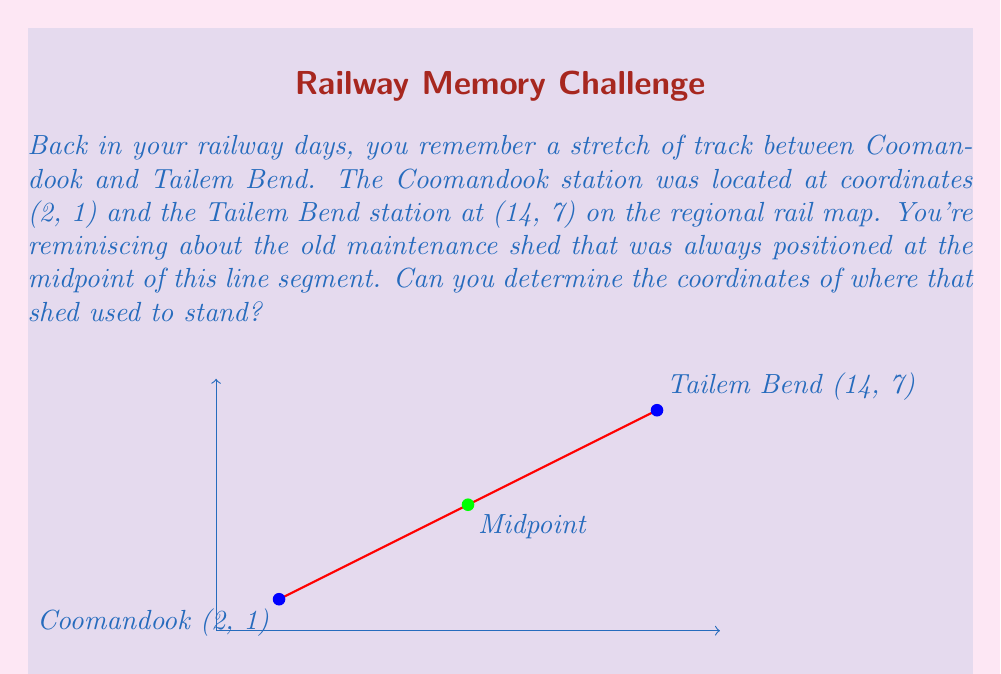Could you help me with this problem? To find the midpoint of a line segment, we use the midpoint formula:

$$ \text{Midpoint} = \left(\frac{x_1 + x_2}{2}, \frac{y_1 + y_2}{2}\right) $$

Where $(x_1, y_1)$ is the coordinate of one endpoint and $(x_2, y_2)$ is the coordinate of the other endpoint.

Given:
- Coomandook station: $(x_1, y_1) = (2, 1)$
- Tailem Bend station: $(x_2, y_2) = (14, 7)$

Step 1: Calculate the x-coordinate of the midpoint:
$$ x = \frac{x_1 + x_2}{2} = \frac{2 + 14}{2} = \frac{16}{2} = 8 $$

Step 2: Calculate the y-coordinate of the midpoint:
$$ y = \frac{y_1 + y_2}{2} = \frac{1 + 7}{2} = \frac{8}{2} = 4 $$

Therefore, the coordinates of the midpoint where the maintenance shed used to stand are (8, 4).
Answer: (8, 4) 